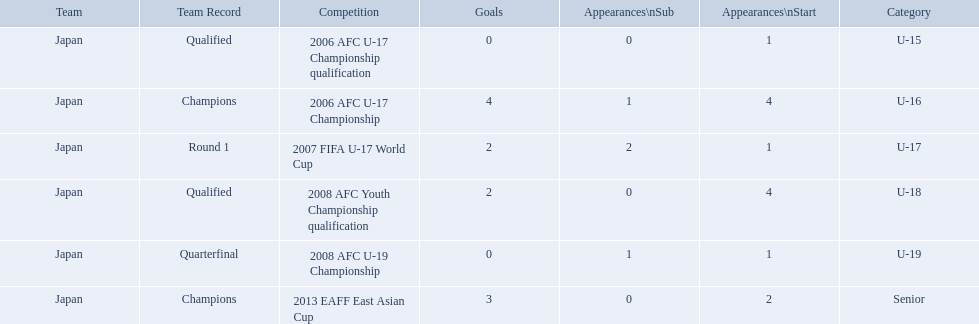What are all of the competitions? 2006 AFC U-17 Championship qualification, 2006 AFC U-17 Championship, 2007 FIFA U-17 World Cup, 2008 AFC Youth Championship qualification, 2008 AFC U-19 Championship, 2013 EAFF East Asian Cup. How many starting appearances were there? 1, 4, 1, 4, 1, 2. What about just during 2013 eaff east asian cup and 2007 fifa u-17 world cup? 1, 2. Which of those had more starting appearances? 2013 EAFF East Asian Cup. 